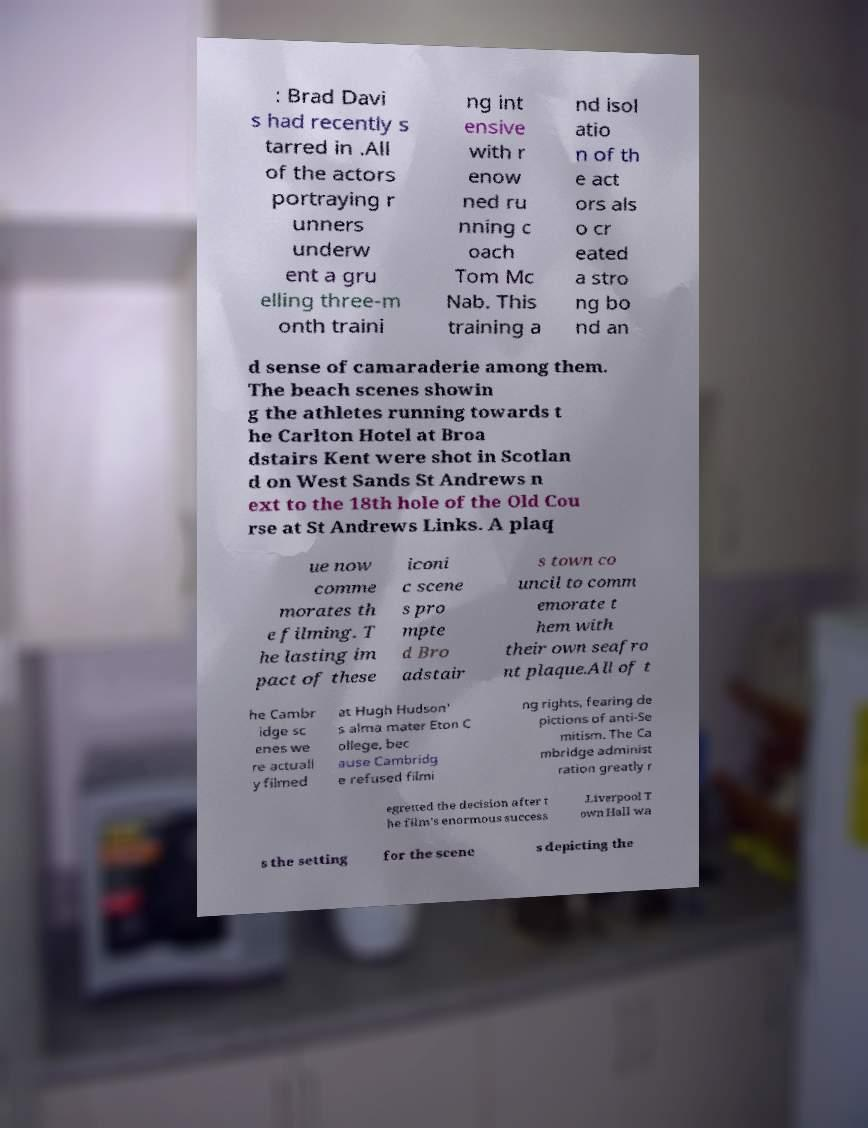Can you accurately transcribe the text from the provided image for me? : Brad Davi s had recently s tarred in .All of the actors portraying r unners underw ent a gru elling three-m onth traini ng int ensive with r enow ned ru nning c oach Tom Mc Nab. This training a nd isol atio n of th e act ors als o cr eated a stro ng bo nd an d sense of camaraderie among them. The beach scenes showin g the athletes running towards t he Carlton Hotel at Broa dstairs Kent were shot in Scotlan d on West Sands St Andrews n ext to the 18th hole of the Old Cou rse at St Andrews Links. A plaq ue now comme morates th e filming. T he lasting im pact of these iconi c scene s pro mpte d Bro adstair s town co uncil to comm emorate t hem with their own seafro nt plaque.All of t he Cambr idge sc enes we re actuall y filmed at Hugh Hudson' s alma mater Eton C ollege, bec ause Cambridg e refused filmi ng rights, fearing de pictions of anti-Se mitism. The Ca mbridge administ ration greatly r egretted the decision after t he film's enormous success .Liverpool T own Hall wa s the setting for the scene s depicting the 